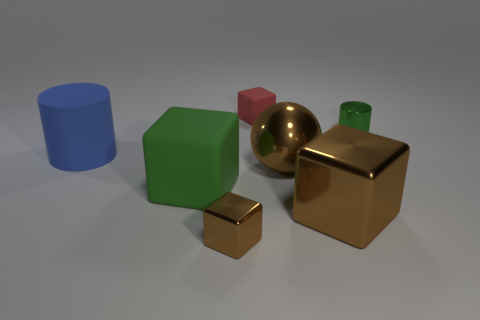Subtract all green blocks. How many blocks are left? 3 Add 1 tiny cyan blocks. How many objects exist? 8 Subtract all green blocks. How many blocks are left? 3 Subtract 1 balls. How many balls are left? 0 Subtract all blue balls. How many red blocks are left? 1 Subtract all red cubes. Subtract all cyan cylinders. How many cubes are left? 3 Subtract all small gray matte cubes. Subtract all brown cubes. How many objects are left? 5 Add 6 tiny brown metallic things. How many tiny brown metallic things are left? 7 Add 1 purple metallic blocks. How many purple metallic blocks exist? 1 Subtract 0 purple blocks. How many objects are left? 7 